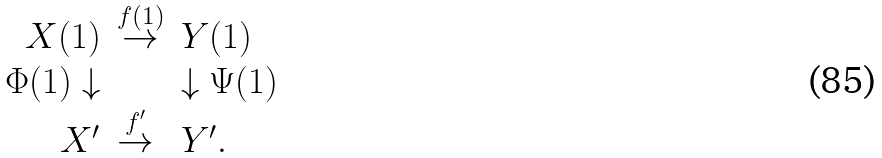<formula> <loc_0><loc_0><loc_500><loc_500>\begin{array} { r l l } X ( 1 ) & \stackrel { f ( 1 ) } { \rightarrow } & Y ( 1 ) \\ \Phi ( 1 ) \downarrow & & \downarrow \Psi ( 1 ) \\ X ^ { \prime } & \stackrel { f ^ { \prime } } { \rightarrow } & Y ^ { \prime } . \end{array}</formula> 